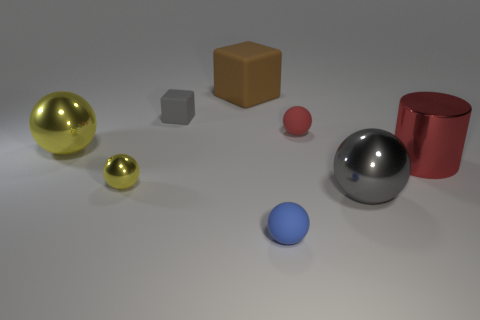Subtract all purple cubes. How many yellow spheres are left? 2 Subtract all large gray spheres. How many spheres are left? 4 Subtract all gray spheres. How many spheres are left? 4 Add 1 blue matte objects. How many objects exist? 9 Subtract all cyan balls. Subtract all purple blocks. How many balls are left? 5 Subtract all cylinders. How many objects are left? 7 Subtract all tiny gray spheres. Subtract all large objects. How many objects are left? 4 Add 3 large red metal cylinders. How many large red metal cylinders are left? 4 Add 1 brown matte things. How many brown matte things exist? 2 Subtract 1 red spheres. How many objects are left? 7 